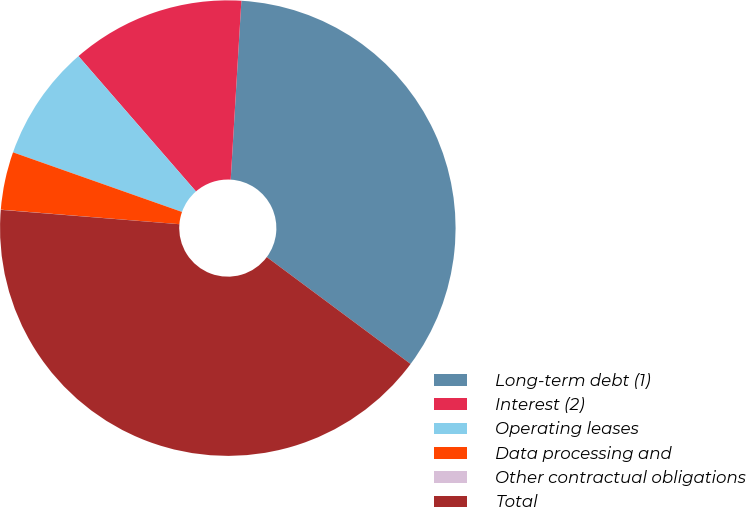Convert chart. <chart><loc_0><loc_0><loc_500><loc_500><pie_chart><fcel>Long-term debt (1)<fcel>Interest (2)<fcel>Operating leases<fcel>Data processing and<fcel>Other contractual obligations<fcel>Total<nl><fcel>34.22%<fcel>12.33%<fcel>8.22%<fcel>4.11%<fcel>0.01%<fcel>41.1%<nl></chart> 